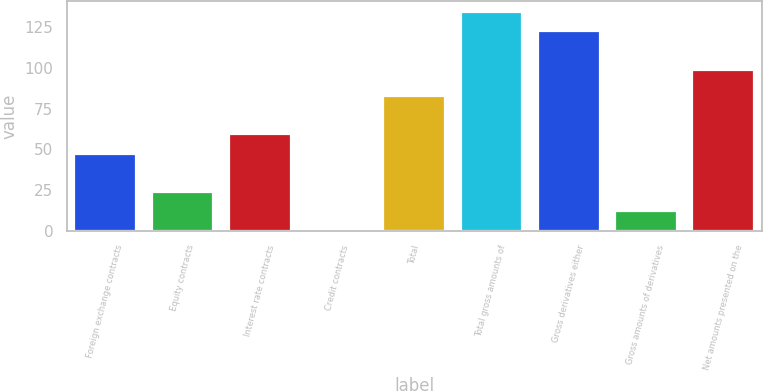Convert chart. <chart><loc_0><loc_0><loc_500><loc_500><bar_chart><fcel>Foreign exchange contracts<fcel>Equity contracts<fcel>Interest rate contracts<fcel>Credit contracts<fcel>Total<fcel>Total gross amounts of<fcel>Gross derivatives either<fcel>Gross amounts of derivatives<fcel>Net amounts presented on the<nl><fcel>47.37<fcel>23.83<fcel>59.14<fcel>0.29<fcel>82.68<fcel>134.31<fcel>122.54<fcel>12.06<fcel>99<nl></chart> 